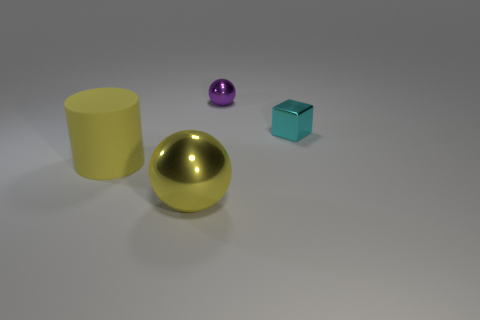Add 1 large yellow cylinders. How many objects exist? 5 Subtract 0 brown cubes. How many objects are left? 4 Subtract all cylinders. How many objects are left? 3 Subtract 1 cylinders. How many cylinders are left? 0 Subtract all blue cylinders. Subtract all red cubes. How many cylinders are left? 1 Subtract all blue cylinders. Subtract all balls. How many objects are left? 2 Add 3 big yellow rubber cylinders. How many big yellow rubber cylinders are left? 4 Add 3 large yellow metallic objects. How many large yellow metallic objects exist? 4 